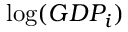<formula> <loc_0><loc_0><loc_500><loc_500>\log ( G D P _ { i } )</formula> 